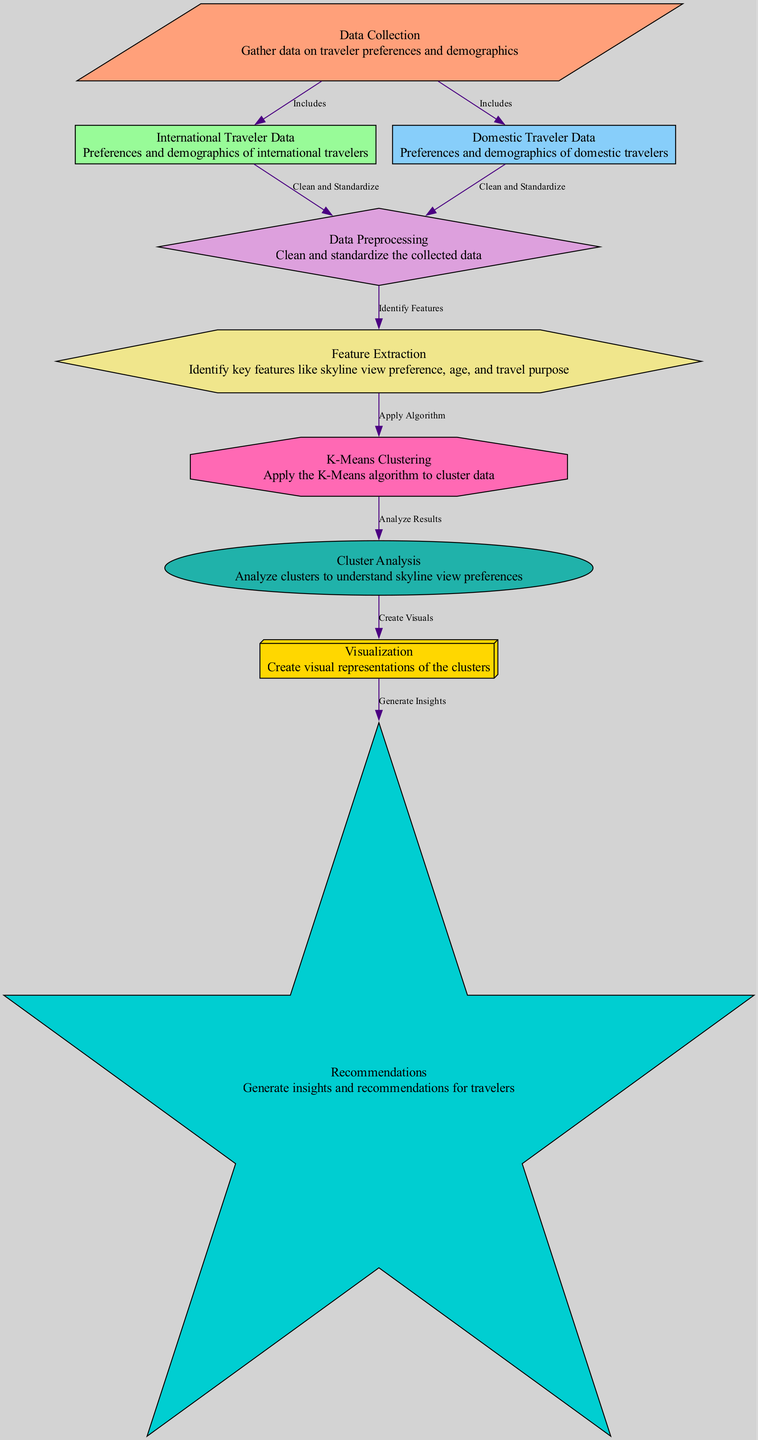What is the first step in the diagram? The diagram starts with the "Data Collection" node, which indicates that gathering data on traveler preferences and demographics is the initial step in the process.
Answer: Data Collection How many types of traveler data are included? In the diagram, there are two types of traveler data shown—"International Traveler Data" and "Domestic Traveler Data," indicating a segmentation based on travel origin.
Answer: Two What is the shape of the "Data Preprocessing" node? The "Data Preprocessing" node is represented as a diamond shape, which is typically used to signify decision points or processes in flow diagrams.
Answer: Diamond Which node comes after feature extraction? After "Feature Extraction," the next node is "K-Means Clustering," which follows the application of the K-Means algorithm to the identified features.
Answer: K-Means Clustering What is the relationship between cluster analysis and visualization? The relationship is that "Cluster Analysis" leads to "Visualization," meaning that the results from analyzing clusters are used to create visual representations.
Answer: Create Visuals What key aspects are involved in feature extraction? The key aspects in "Feature Extraction" involve identifying crucial features such as skyline view preference, age, and travel purpose, which are necessary for clustering.
Answer: Skyline view preference, age, travel purpose How does the K-Means algorithm relate to cluster analysis? The K-Means algorithm is applied to the data resulting in clusters that are then analyzed in the "Cluster Analysis" node to understand traveler preferences.
Answer: Analyze Results What comes as the final output of the process? The final output of the process is the "Recommendations" node, where insights and recommendations for travelers are generated based on the earlier steps.
Answer: Recommendations 